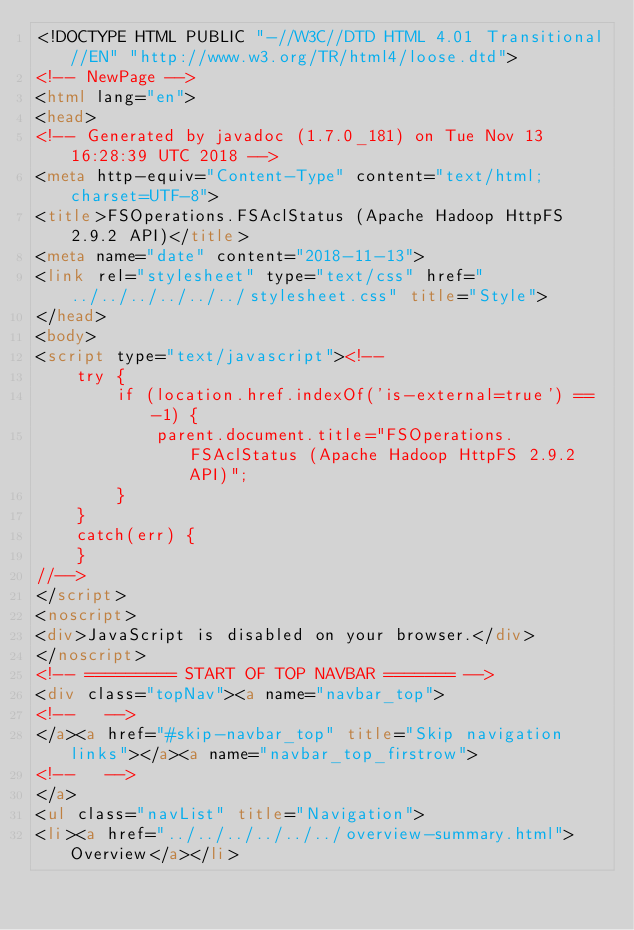<code> <loc_0><loc_0><loc_500><loc_500><_HTML_><!DOCTYPE HTML PUBLIC "-//W3C//DTD HTML 4.01 Transitional//EN" "http://www.w3.org/TR/html4/loose.dtd">
<!-- NewPage -->
<html lang="en">
<head>
<!-- Generated by javadoc (1.7.0_181) on Tue Nov 13 16:28:39 UTC 2018 -->
<meta http-equiv="Content-Type" content="text/html; charset=UTF-8">
<title>FSOperations.FSAclStatus (Apache Hadoop HttpFS 2.9.2 API)</title>
<meta name="date" content="2018-11-13">
<link rel="stylesheet" type="text/css" href="../../../../../../stylesheet.css" title="Style">
</head>
<body>
<script type="text/javascript"><!--
    try {
        if (location.href.indexOf('is-external=true') == -1) {
            parent.document.title="FSOperations.FSAclStatus (Apache Hadoop HttpFS 2.9.2 API)";
        }
    }
    catch(err) {
    }
//-->
</script>
<noscript>
<div>JavaScript is disabled on your browser.</div>
</noscript>
<!-- ========= START OF TOP NAVBAR ======= -->
<div class="topNav"><a name="navbar_top">
<!--   -->
</a><a href="#skip-navbar_top" title="Skip navigation links"></a><a name="navbar_top_firstrow">
<!--   -->
</a>
<ul class="navList" title="Navigation">
<li><a href="../../../../../../overview-summary.html">Overview</a></li></code> 